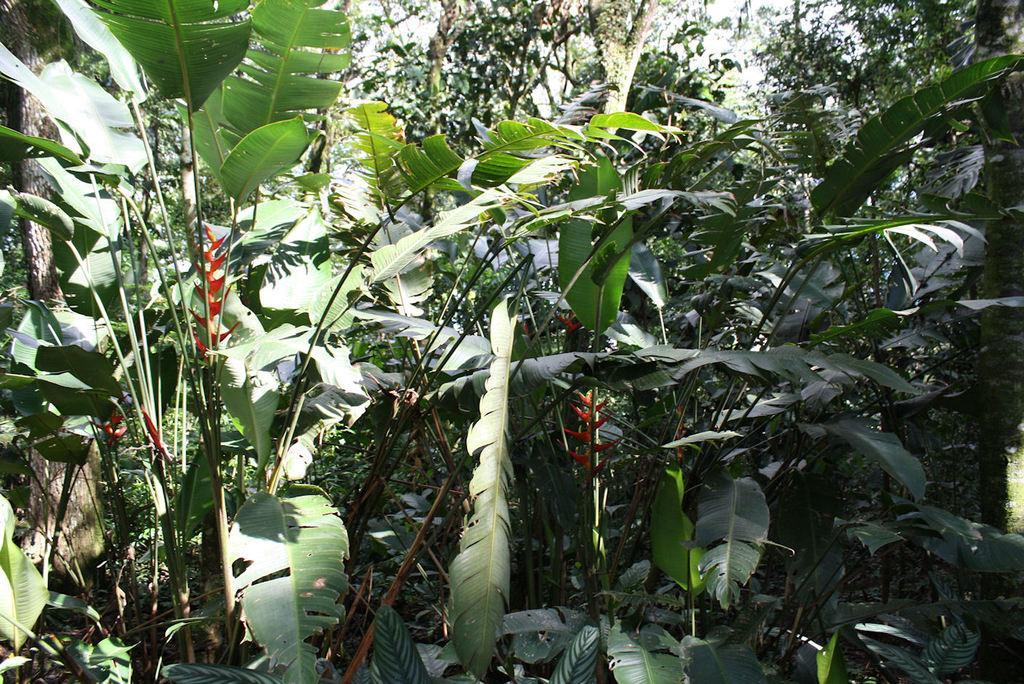Please provide a concise description of this image. As we can see in the image there are trees and at the top there is sky. 